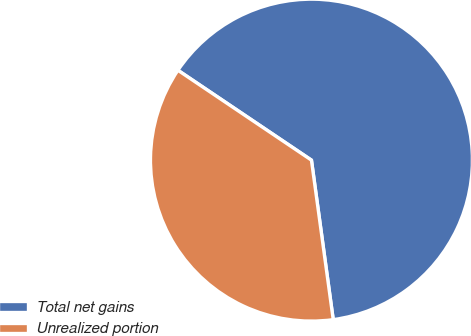Convert chart to OTSL. <chart><loc_0><loc_0><loc_500><loc_500><pie_chart><fcel>Total net gains<fcel>Unrealized portion<nl><fcel>63.41%<fcel>36.59%<nl></chart> 